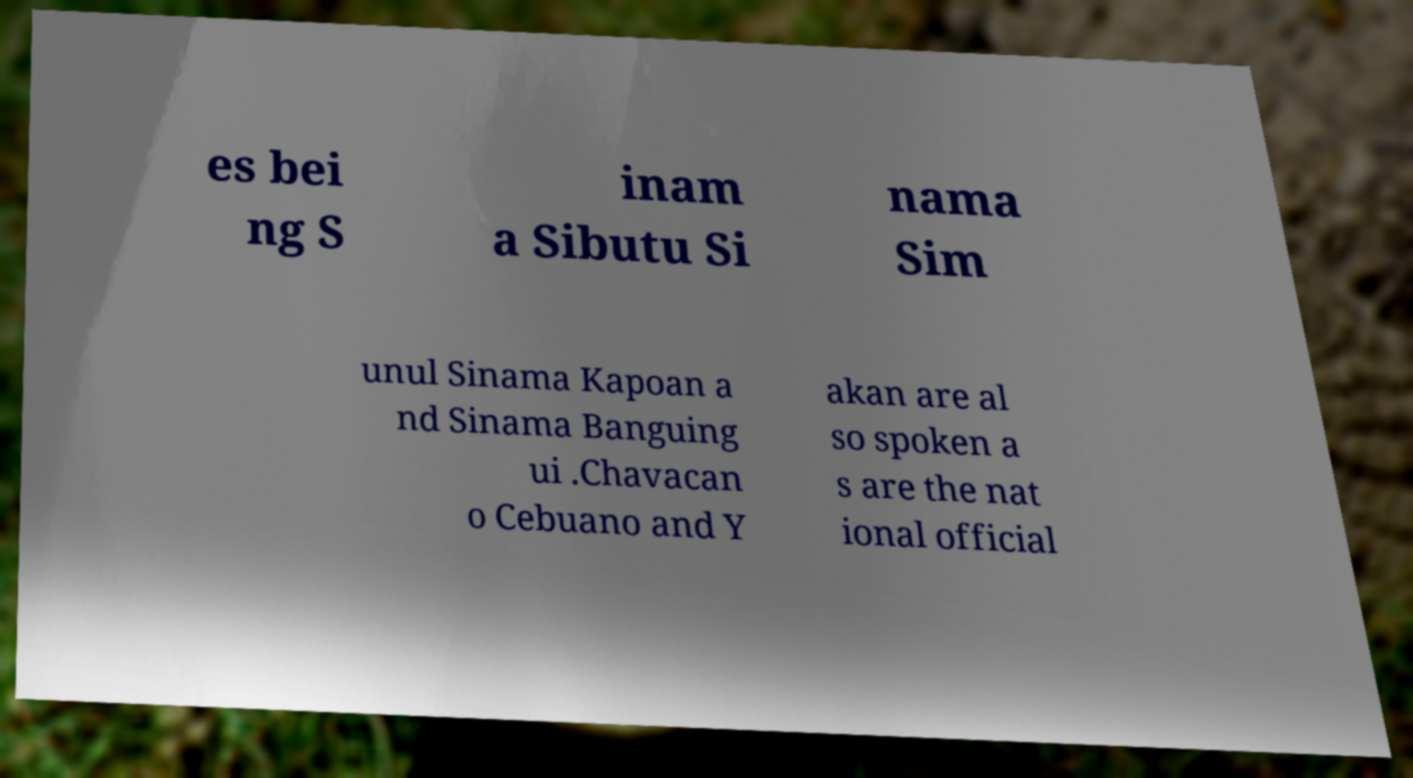Please read and relay the text visible in this image. What does it say? es bei ng S inam a Sibutu Si nama Sim unul Sinama Kapoan a nd Sinama Banguing ui .Chavacan o Cebuano and Y akan are al so spoken a s are the nat ional official 